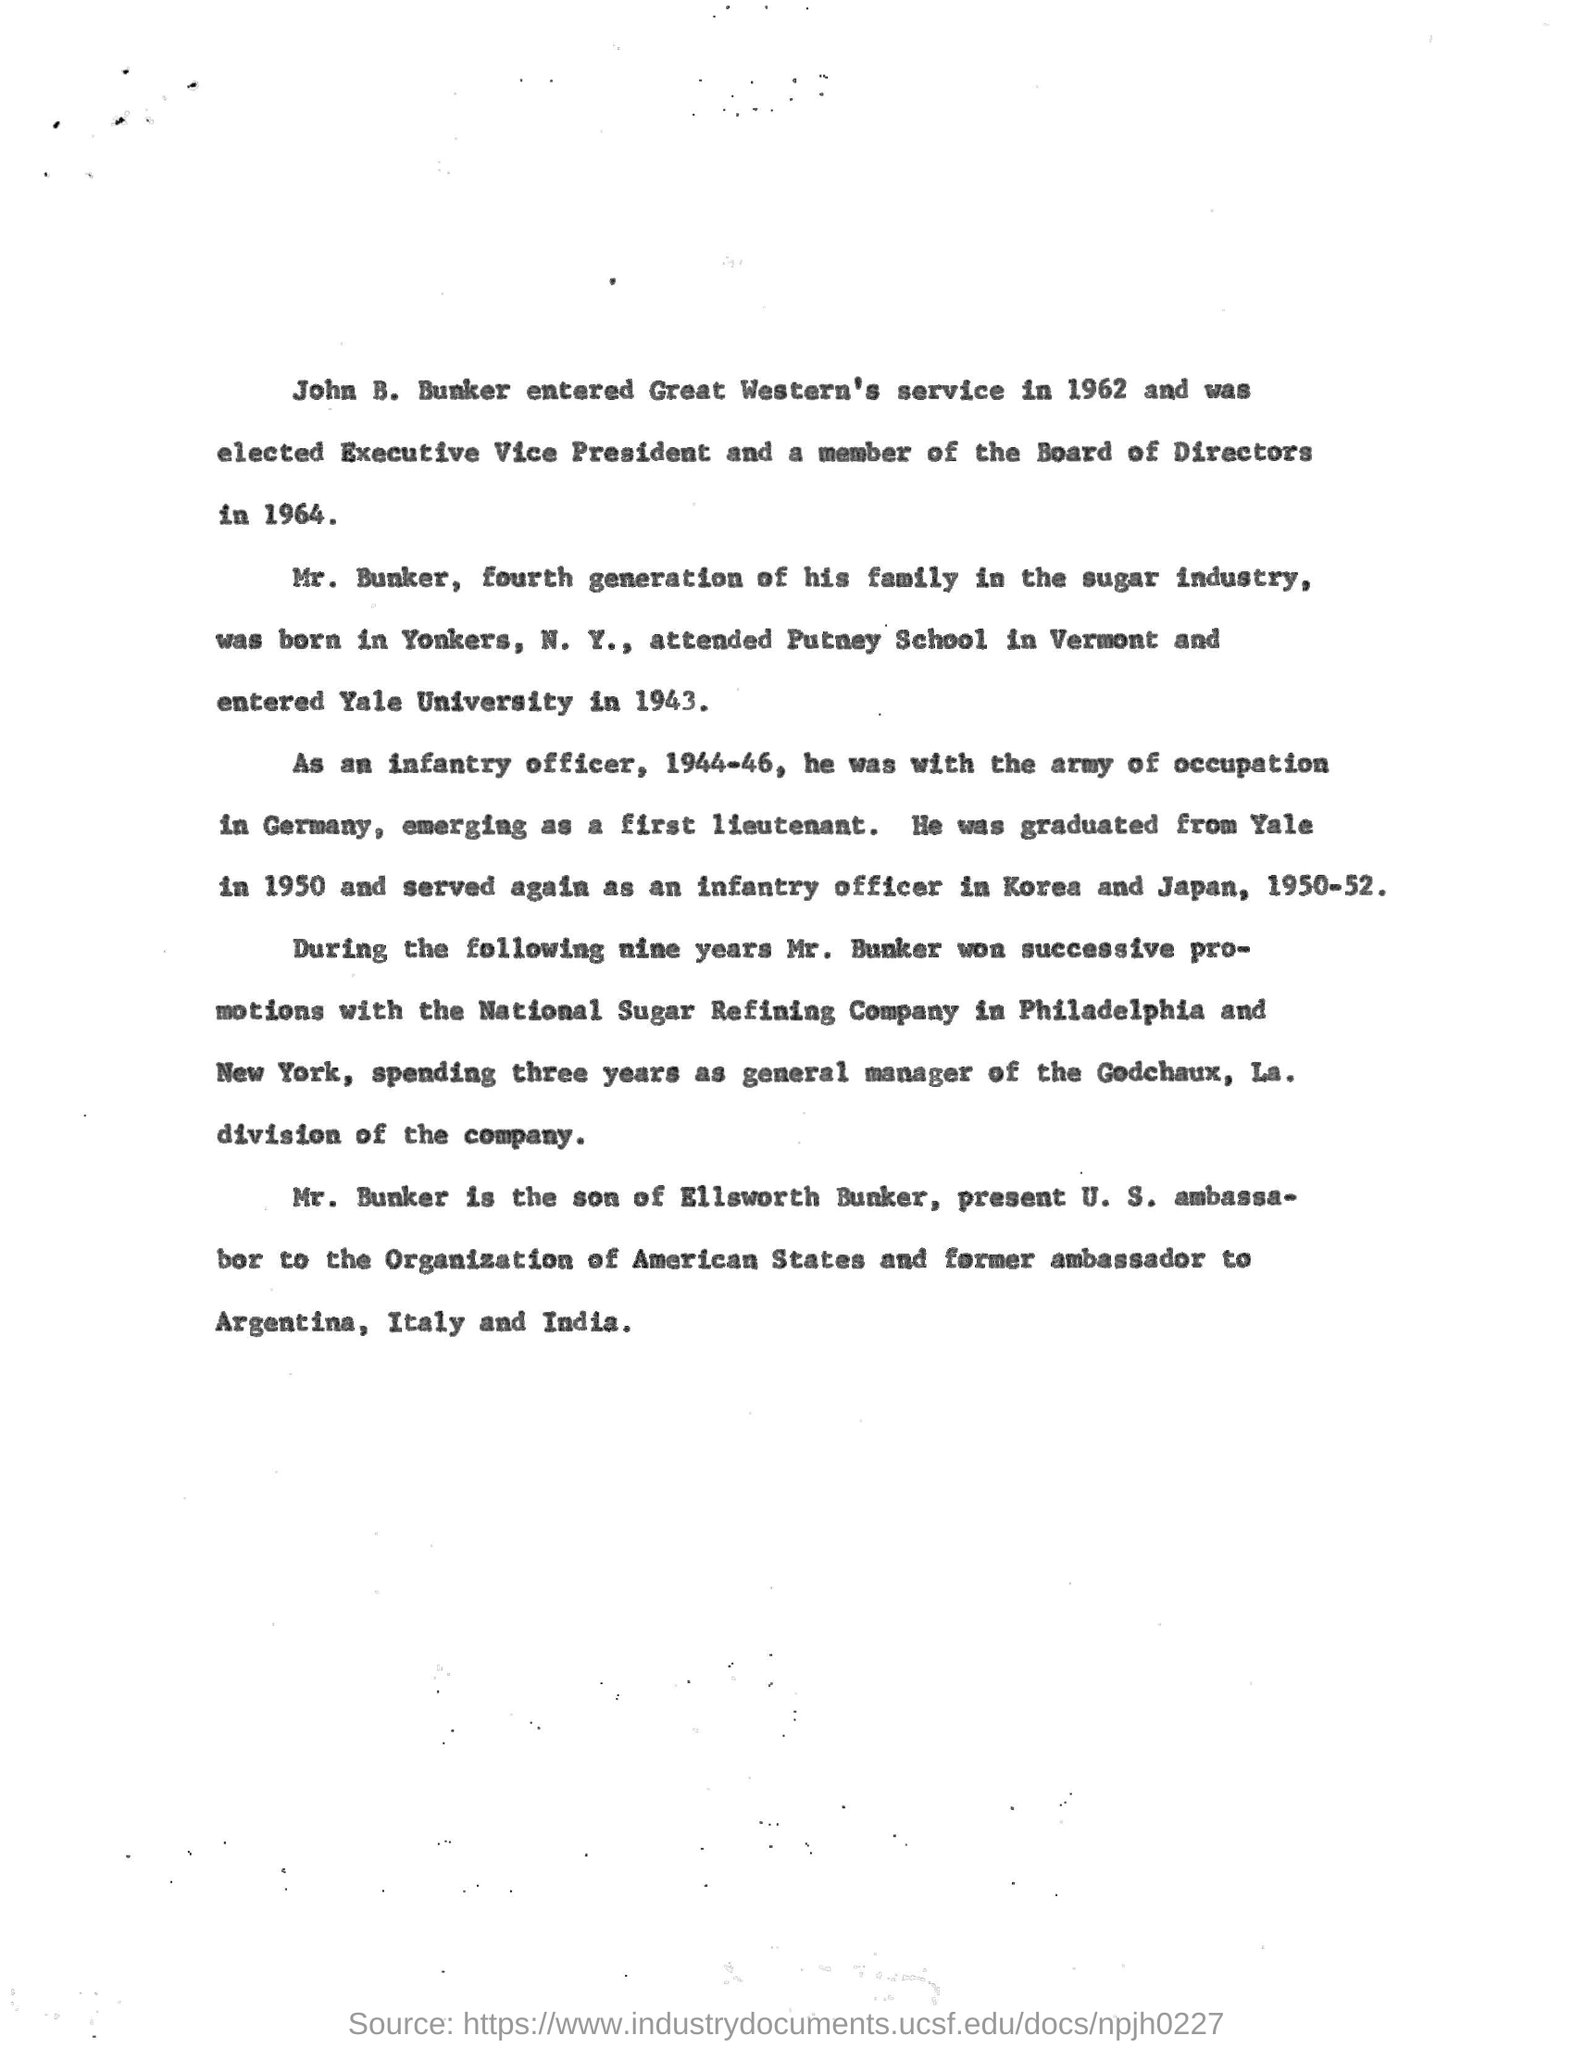Indicate a few pertinent items in this graphic. John B. Bunker entered Yale University in 1943. John B. Bunker received his undergraduate degree from Yale University. In 1964, John B. Bunker was elected as the Executive Vice President. John B. Bunker is the son of Ellsworth Bunker. Mr. Bunker was born in Yonkers, New York. 